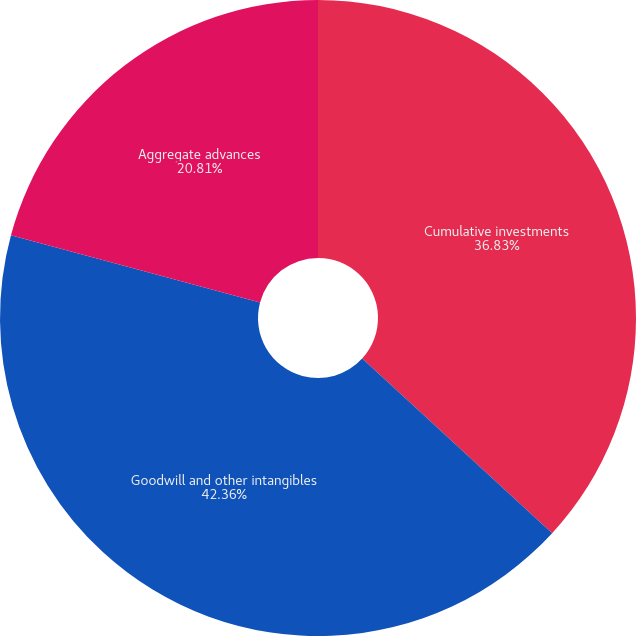Convert chart. <chart><loc_0><loc_0><loc_500><loc_500><pie_chart><fcel>Cumulative investments<fcel>Goodwill and other intangibles<fcel>Aggregate advances<nl><fcel>36.83%<fcel>42.36%<fcel>20.81%<nl></chart> 